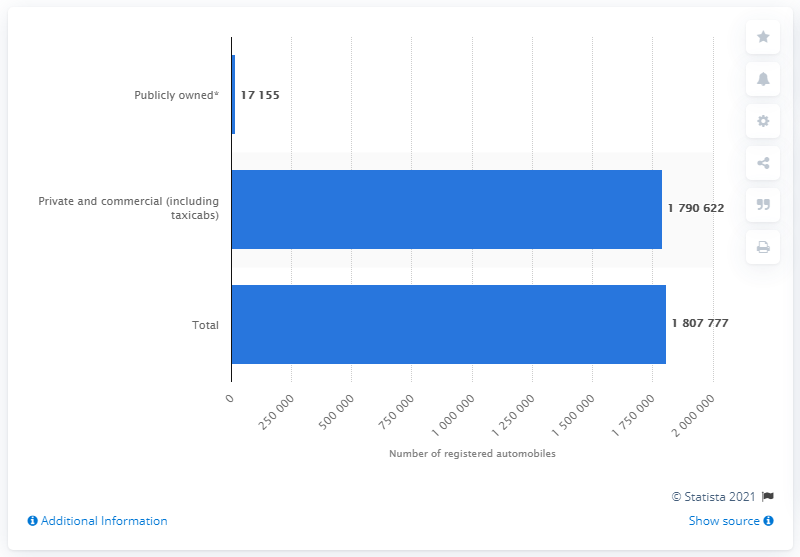List a handful of essential elements in this visual. In the year 2016, a total of 1,790,622 private and commercial automobiles were registered in the state of Colorado. 